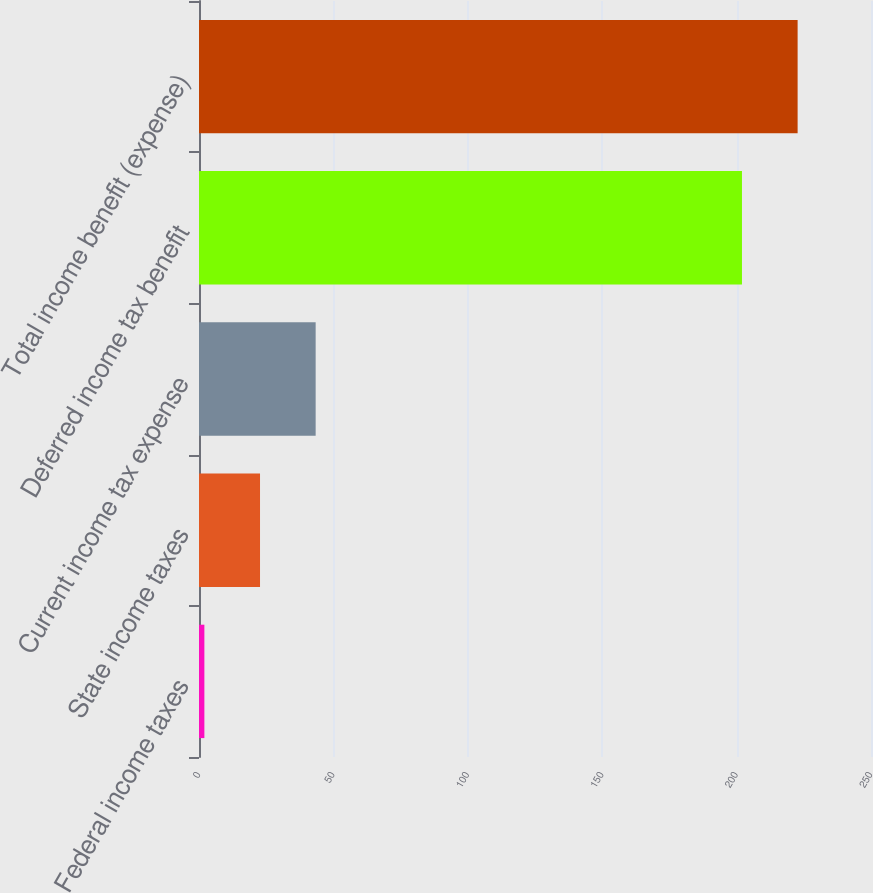Convert chart. <chart><loc_0><loc_0><loc_500><loc_500><bar_chart><fcel>Federal income taxes<fcel>State income taxes<fcel>Current income tax expense<fcel>Deferred income tax benefit<fcel>Total income benefit (expense)<nl><fcel>2<fcel>22.7<fcel>43.4<fcel>202<fcel>222.7<nl></chart> 